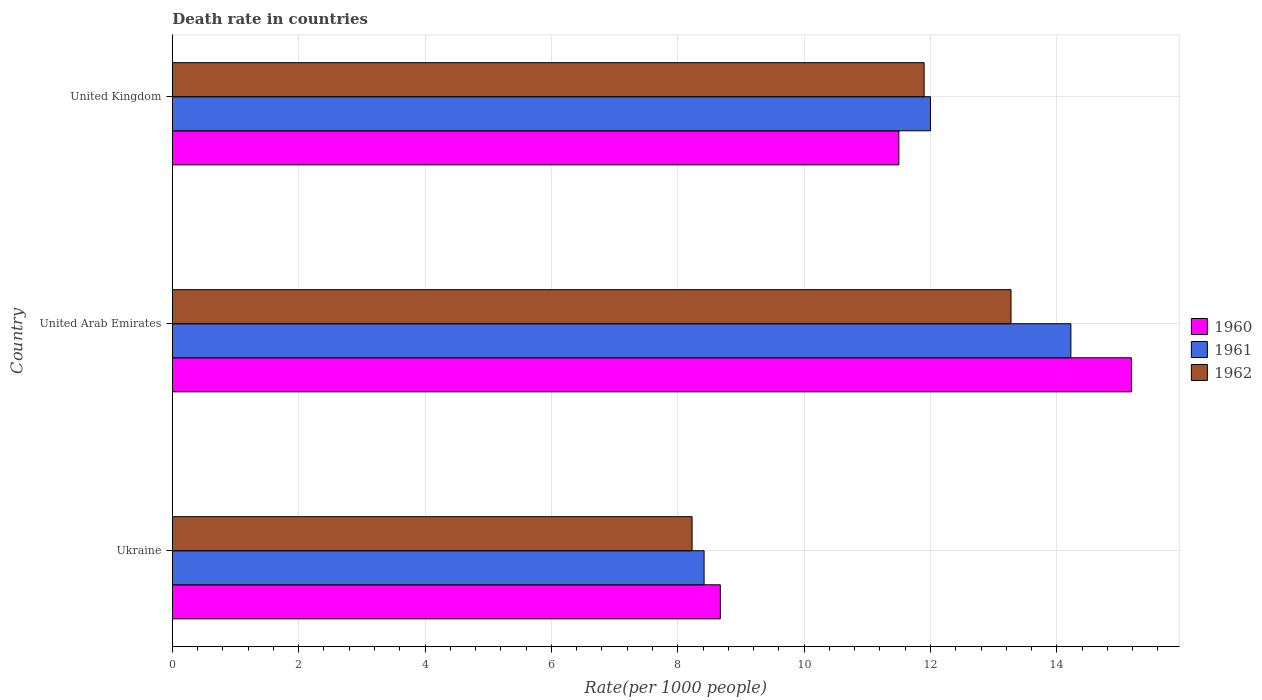How many groups of bars are there?
Ensure brevity in your answer.  3. Are the number of bars on each tick of the Y-axis equal?
Make the answer very short. Yes. How many bars are there on the 3rd tick from the bottom?
Your answer should be compact. 3. What is the label of the 2nd group of bars from the top?
Your answer should be compact. United Arab Emirates. In how many cases, is the number of bars for a given country not equal to the number of legend labels?
Your response must be concise. 0. Across all countries, what is the maximum death rate in 1962?
Provide a short and direct response. 13.28. Across all countries, what is the minimum death rate in 1960?
Your response must be concise. 8.67. In which country was the death rate in 1962 maximum?
Make the answer very short. United Arab Emirates. In which country was the death rate in 1962 minimum?
Offer a very short reply. Ukraine. What is the total death rate in 1960 in the graph?
Offer a very short reply. 35.35. What is the difference between the death rate in 1962 in Ukraine and that in United Kingdom?
Give a very brief answer. -3.67. What is the difference between the death rate in 1960 in United Kingdom and the death rate in 1962 in United Arab Emirates?
Give a very brief answer. -1.78. What is the average death rate in 1961 per country?
Provide a succinct answer. 11.55. What is the difference between the death rate in 1960 and death rate in 1962 in United Kingdom?
Your response must be concise. -0.4. In how many countries, is the death rate in 1961 greater than 14.4 ?
Make the answer very short. 0. What is the ratio of the death rate in 1960 in Ukraine to that in United Kingdom?
Provide a short and direct response. 0.75. What is the difference between the highest and the second highest death rate in 1961?
Offer a terse response. 2.22. What is the difference between the highest and the lowest death rate in 1962?
Ensure brevity in your answer.  5.05. In how many countries, is the death rate in 1962 greater than the average death rate in 1962 taken over all countries?
Keep it short and to the point. 2. Is the sum of the death rate in 1960 in Ukraine and United Arab Emirates greater than the maximum death rate in 1962 across all countries?
Offer a very short reply. Yes. How many bars are there?
Offer a terse response. 9. Are all the bars in the graph horizontal?
Offer a terse response. Yes. How many legend labels are there?
Keep it short and to the point. 3. What is the title of the graph?
Offer a very short reply. Death rate in countries. Does "1963" appear as one of the legend labels in the graph?
Keep it short and to the point. No. What is the label or title of the X-axis?
Offer a terse response. Rate(per 1000 people). What is the Rate(per 1000 people) in 1960 in Ukraine?
Your response must be concise. 8.67. What is the Rate(per 1000 people) of 1961 in Ukraine?
Ensure brevity in your answer.  8.42. What is the Rate(per 1000 people) of 1962 in Ukraine?
Offer a very short reply. 8.23. What is the Rate(per 1000 people) of 1960 in United Arab Emirates?
Provide a short and direct response. 15.18. What is the Rate(per 1000 people) in 1961 in United Arab Emirates?
Offer a terse response. 14.22. What is the Rate(per 1000 people) in 1962 in United Arab Emirates?
Provide a short and direct response. 13.28. What is the Rate(per 1000 people) in 1962 in United Kingdom?
Provide a short and direct response. 11.9. Across all countries, what is the maximum Rate(per 1000 people) of 1960?
Provide a succinct answer. 15.18. Across all countries, what is the maximum Rate(per 1000 people) in 1961?
Ensure brevity in your answer.  14.22. Across all countries, what is the maximum Rate(per 1000 people) of 1962?
Make the answer very short. 13.28. Across all countries, what is the minimum Rate(per 1000 people) of 1960?
Make the answer very short. 8.67. Across all countries, what is the minimum Rate(per 1000 people) in 1961?
Ensure brevity in your answer.  8.42. Across all countries, what is the minimum Rate(per 1000 people) of 1962?
Give a very brief answer. 8.23. What is the total Rate(per 1000 people) in 1960 in the graph?
Give a very brief answer. 35.35. What is the total Rate(per 1000 people) in 1961 in the graph?
Your answer should be very brief. 34.64. What is the total Rate(per 1000 people) in 1962 in the graph?
Provide a short and direct response. 33.4. What is the difference between the Rate(per 1000 people) in 1960 in Ukraine and that in United Arab Emirates?
Your answer should be compact. -6.51. What is the difference between the Rate(per 1000 people) in 1961 in Ukraine and that in United Arab Emirates?
Your answer should be very brief. -5.81. What is the difference between the Rate(per 1000 people) of 1962 in Ukraine and that in United Arab Emirates?
Offer a very short reply. -5.05. What is the difference between the Rate(per 1000 people) in 1960 in Ukraine and that in United Kingdom?
Your answer should be compact. -2.83. What is the difference between the Rate(per 1000 people) in 1961 in Ukraine and that in United Kingdom?
Offer a very short reply. -3.58. What is the difference between the Rate(per 1000 people) in 1962 in Ukraine and that in United Kingdom?
Provide a short and direct response. -3.67. What is the difference between the Rate(per 1000 people) of 1960 in United Arab Emirates and that in United Kingdom?
Ensure brevity in your answer.  3.68. What is the difference between the Rate(per 1000 people) in 1961 in United Arab Emirates and that in United Kingdom?
Make the answer very short. 2.22. What is the difference between the Rate(per 1000 people) of 1962 in United Arab Emirates and that in United Kingdom?
Your response must be concise. 1.38. What is the difference between the Rate(per 1000 people) in 1960 in Ukraine and the Rate(per 1000 people) in 1961 in United Arab Emirates?
Your response must be concise. -5.55. What is the difference between the Rate(per 1000 people) in 1960 in Ukraine and the Rate(per 1000 people) in 1962 in United Arab Emirates?
Offer a very short reply. -4.6. What is the difference between the Rate(per 1000 people) in 1961 in Ukraine and the Rate(per 1000 people) in 1962 in United Arab Emirates?
Ensure brevity in your answer.  -4.86. What is the difference between the Rate(per 1000 people) in 1960 in Ukraine and the Rate(per 1000 people) in 1961 in United Kingdom?
Offer a very short reply. -3.33. What is the difference between the Rate(per 1000 people) in 1960 in Ukraine and the Rate(per 1000 people) in 1962 in United Kingdom?
Offer a very short reply. -3.23. What is the difference between the Rate(per 1000 people) of 1961 in Ukraine and the Rate(per 1000 people) of 1962 in United Kingdom?
Provide a succinct answer. -3.48. What is the difference between the Rate(per 1000 people) in 1960 in United Arab Emirates and the Rate(per 1000 people) in 1961 in United Kingdom?
Provide a succinct answer. 3.18. What is the difference between the Rate(per 1000 people) in 1960 in United Arab Emirates and the Rate(per 1000 people) in 1962 in United Kingdom?
Provide a short and direct response. 3.28. What is the difference between the Rate(per 1000 people) of 1961 in United Arab Emirates and the Rate(per 1000 people) of 1962 in United Kingdom?
Offer a terse response. 2.32. What is the average Rate(per 1000 people) of 1960 per country?
Give a very brief answer. 11.79. What is the average Rate(per 1000 people) of 1961 per country?
Provide a short and direct response. 11.55. What is the average Rate(per 1000 people) in 1962 per country?
Your response must be concise. 11.13. What is the difference between the Rate(per 1000 people) in 1960 and Rate(per 1000 people) in 1961 in Ukraine?
Provide a succinct answer. 0.26. What is the difference between the Rate(per 1000 people) of 1960 and Rate(per 1000 people) of 1962 in Ukraine?
Provide a short and direct response. 0.45. What is the difference between the Rate(per 1000 people) of 1961 and Rate(per 1000 people) of 1962 in Ukraine?
Offer a terse response. 0.19. What is the difference between the Rate(per 1000 people) in 1960 and Rate(per 1000 people) in 1961 in United Arab Emirates?
Your response must be concise. 0.96. What is the difference between the Rate(per 1000 people) in 1960 and Rate(per 1000 people) in 1962 in United Arab Emirates?
Your answer should be compact. 1.91. What is the difference between the Rate(per 1000 people) in 1961 and Rate(per 1000 people) in 1962 in United Arab Emirates?
Offer a terse response. 0.95. What is the difference between the Rate(per 1000 people) of 1960 and Rate(per 1000 people) of 1961 in United Kingdom?
Offer a very short reply. -0.5. What is the difference between the Rate(per 1000 people) of 1961 and Rate(per 1000 people) of 1962 in United Kingdom?
Make the answer very short. 0.1. What is the ratio of the Rate(per 1000 people) of 1960 in Ukraine to that in United Arab Emirates?
Make the answer very short. 0.57. What is the ratio of the Rate(per 1000 people) of 1961 in Ukraine to that in United Arab Emirates?
Provide a succinct answer. 0.59. What is the ratio of the Rate(per 1000 people) of 1962 in Ukraine to that in United Arab Emirates?
Give a very brief answer. 0.62. What is the ratio of the Rate(per 1000 people) in 1960 in Ukraine to that in United Kingdom?
Make the answer very short. 0.75. What is the ratio of the Rate(per 1000 people) in 1961 in Ukraine to that in United Kingdom?
Keep it short and to the point. 0.7. What is the ratio of the Rate(per 1000 people) in 1962 in Ukraine to that in United Kingdom?
Your answer should be very brief. 0.69. What is the ratio of the Rate(per 1000 people) in 1960 in United Arab Emirates to that in United Kingdom?
Offer a terse response. 1.32. What is the ratio of the Rate(per 1000 people) in 1961 in United Arab Emirates to that in United Kingdom?
Provide a succinct answer. 1.19. What is the ratio of the Rate(per 1000 people) of 1962 in United Arab Emirates to that in United Kingdom?
Provide a succinct answer. 1.12. What is the difference between the highest and the second highest Rate(per 1000 people) of 1960?
Keep it short and to the point. 3.68. What is the difference between the highest and the second highest Rate(per 1000 people) in 1961?
Your answer should be very brief. 2.22. What is the difference between the highest and the second highest Rate(per 1000 people) in 1962?
Keep it short and to the point. 1.38. What is the difference between the highest and the lowest Rate(per 1000 people) in 1960?
Offer a very short reply. 6.51. What is the difference between the highest and the lowest Rate(per 1000 people) in 1961?
Offer a terse response. 5.81. What is the difference between the highest and the lowest Rate(per 1000 people) in 1962?
Your response must be concise. 5.05. 